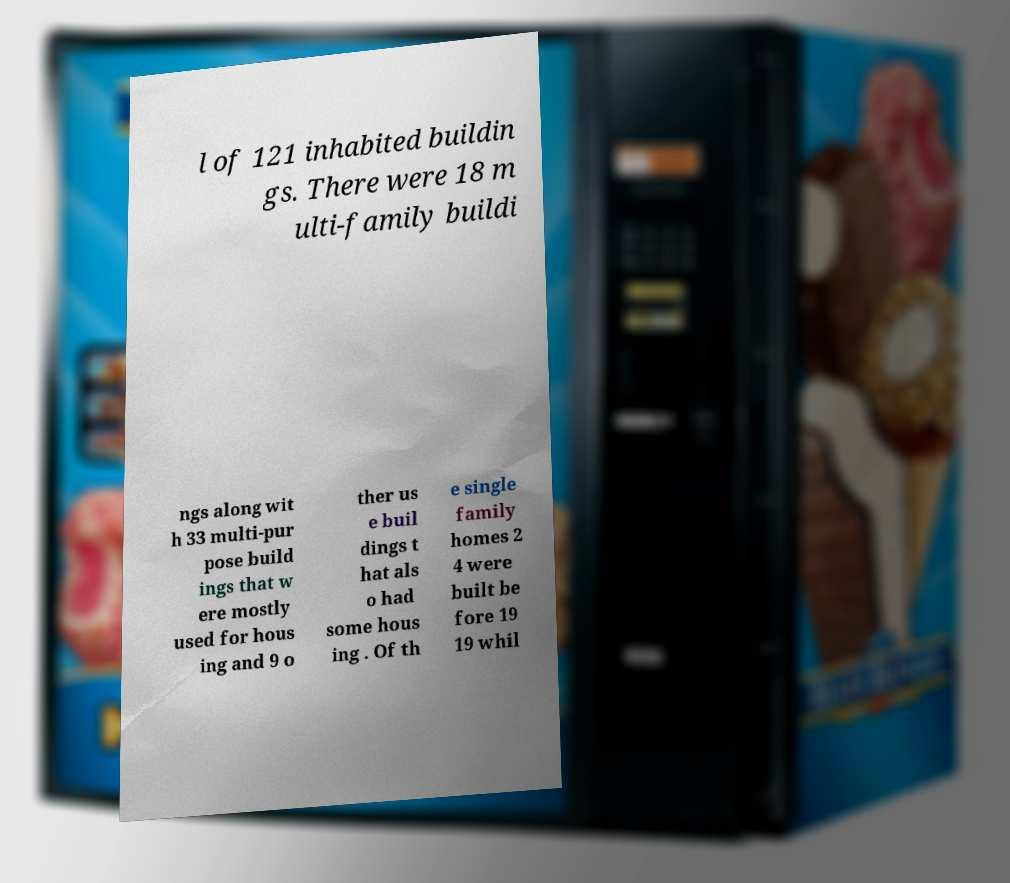Please read and relay the text visible in this image. What does it say? l of 121 inhabited buildin gs. There were 18 m ulti-family buildi ngs along wit h 33 multi-pur pose build ings that w ere mostly used for hous ing and 9 o ther us e buil dings t hat als o had some hous ing . Of th e single family homes 2 4 were built be fore 19 19 whil 